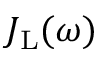<formula> <loc_0><loc_0><loc_500><loc_500>J _ { L } ( \omega )</formula> 